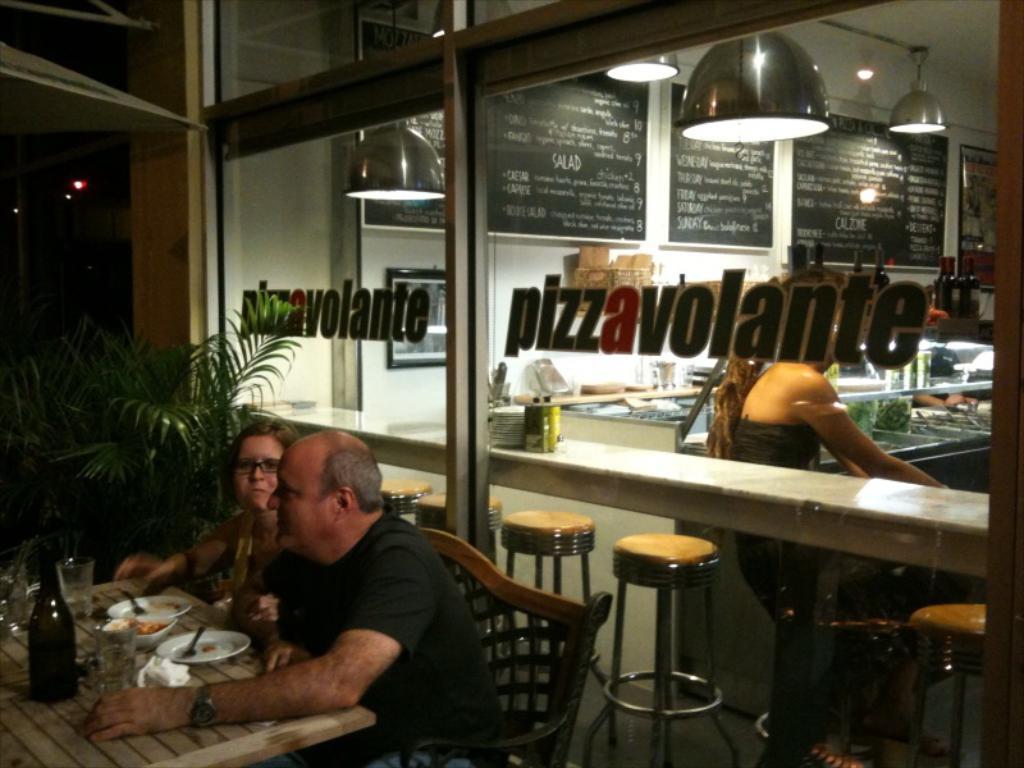How would you summarize this image in a sentence or two? In this picture there is a man who is wearing black dress and watch. He is sitting on the chair. Beside him there is a woman who is wearing spectacle and black dress. Both of them are sitting near to the table. On the table I can see the wine glasses, wine bottles, plates, forks, spoon, tissue papers and food items. Behind them there is a glass partition. On the right I can see the woman who is the sitting near to the table. At the top I can see the lights. 